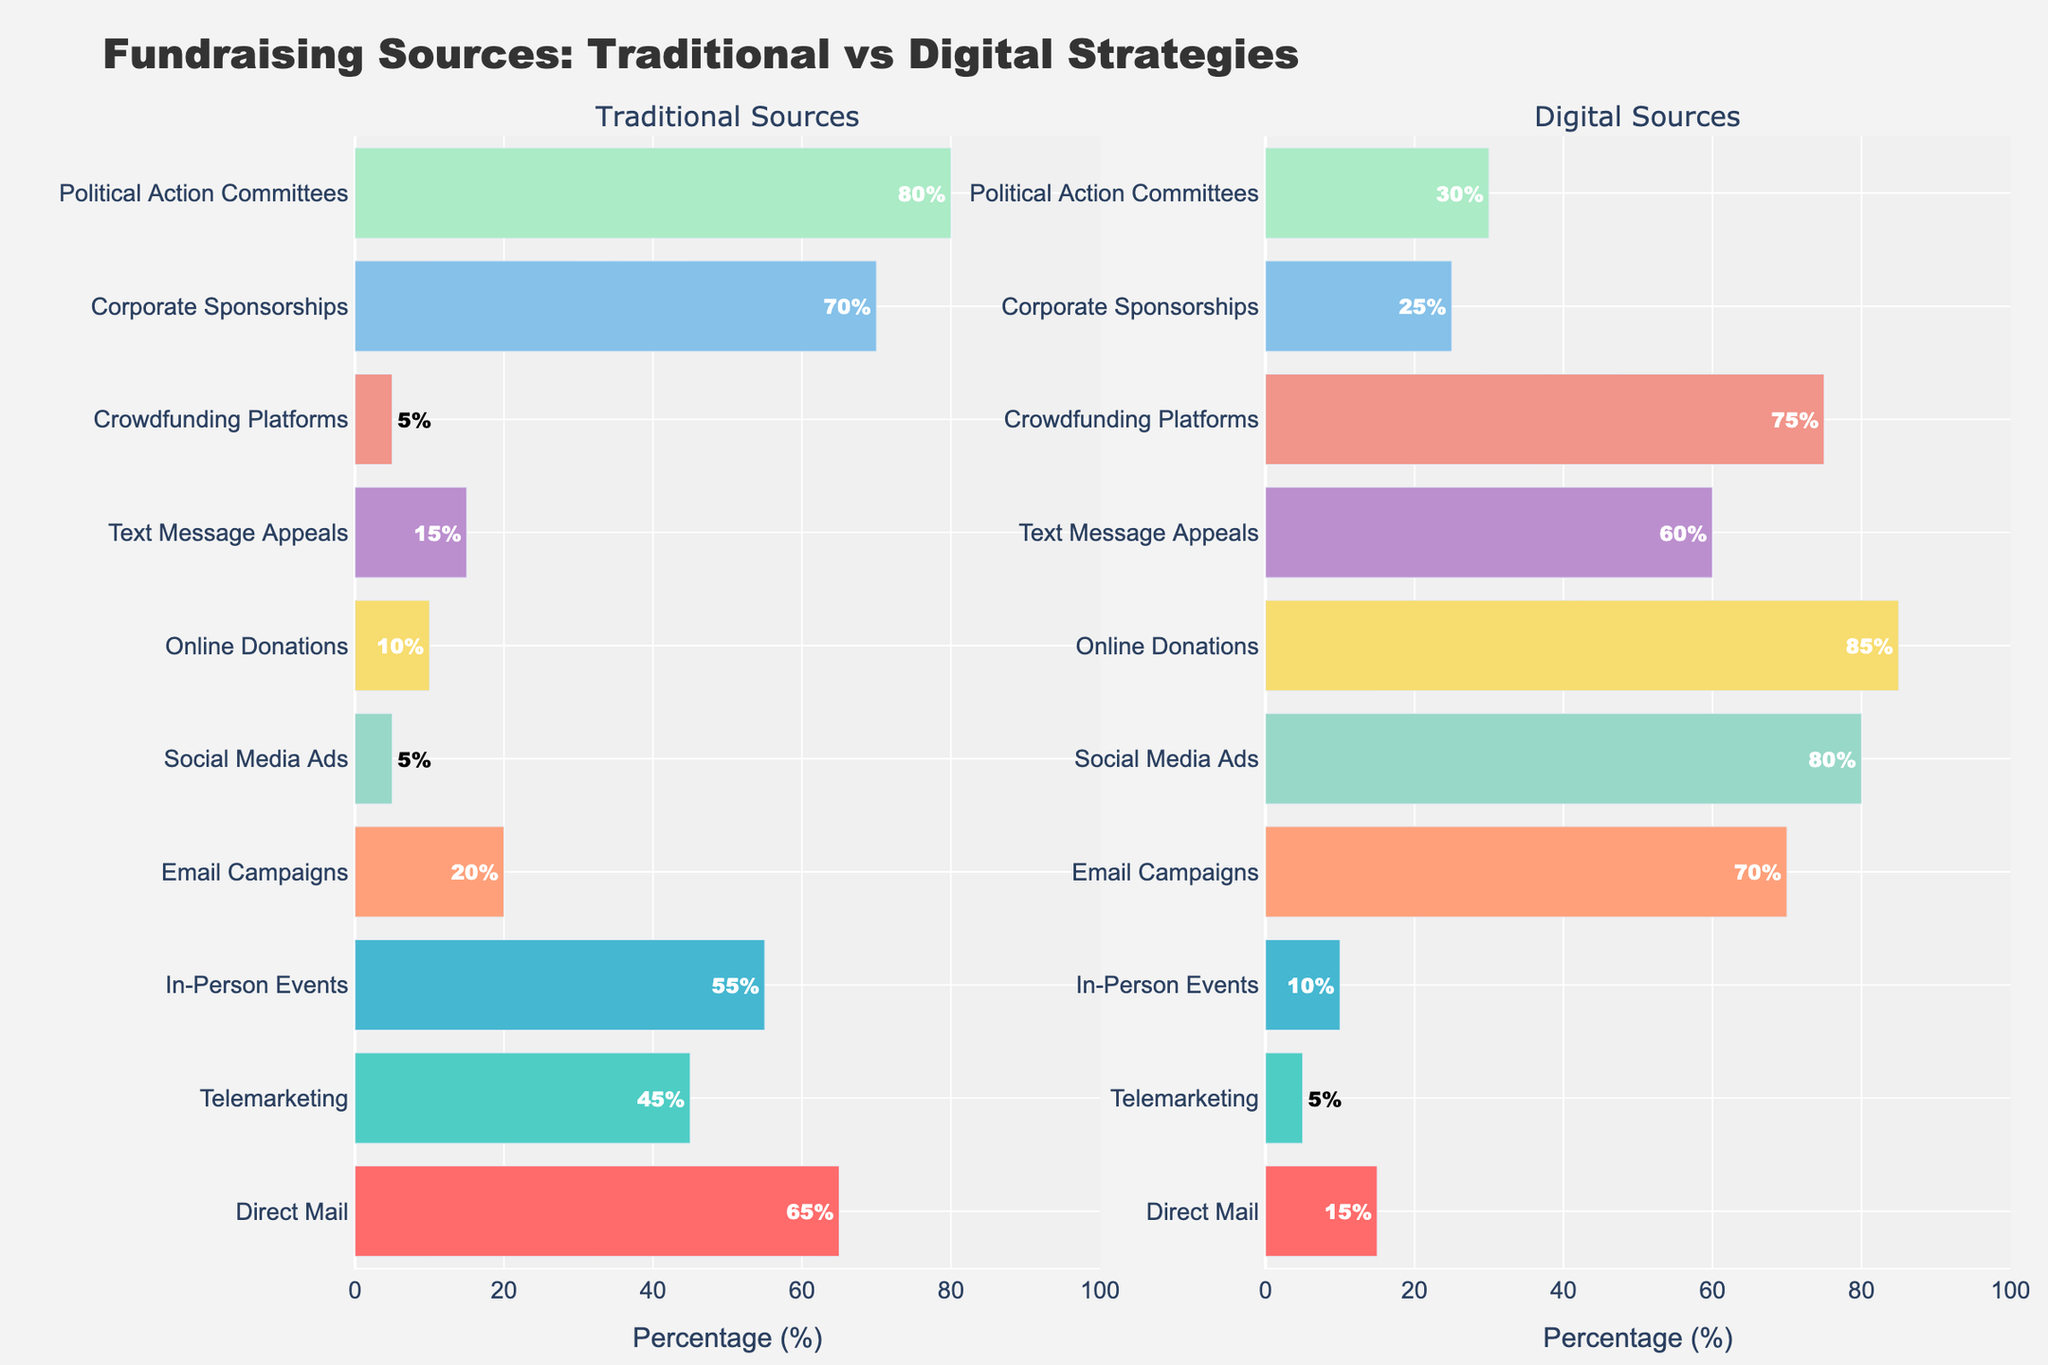What is the title of the subplot on the left? The title of the subplot on the left is given at the top of it.
Answer: Traditional Sources How many strategies have more than 50% in traditional sources? By looking at the bars on the left subplot, the ones that exceed the 50% mark are Direct Mail, Telemarketing, In-Person Events, Corporate Sponsorships, and Political Action Committees.
Answer: 5 Which fundraising source has the highest percentage in digital sources? Locate the longest bar in the right subplot to identify the source with the highest percentage.
Answer: Online Donations Compare the percentages of Direct Mail in traditional and digital sources. Which one is higher and by how much? Direct Mail in traditional sources is 65%, and in digital sources is 15%. The difference is 65% - 15%.
Answer: Traditional, by 50% What is the average percentage of all digital sources? Sum all the percentages of digital sources and divide them by the number of sources. (15 + 5 + 10 + 70 + 80 + 85 + 60 + 75 + 25 + 30) / 10.
Answer: 45.5% Identify the three sources with the lowest percentage in digital campaigns. The shortest bars in the right subplot are for Telemarketing, Direct Mail, and In-Person Events.
Answer: Telemarketing, Direct Mail, In-Person Events Which source has a higher percentage in traditional sources compared to its percentage in digital sources, In-Person Events or Political Action Committees? In-Person Events has 55% in traditional and 10% in digital. Political Action Committees have 80% in traditional and 30% in digital. Both are higher in traditional, but Political Action Committees is higher than In-Person Events in both cases.
Answer: Political Action Committees What is the combined percentage for Social Media Ads and Crowdfunding Platforms in digital sources? Add the percentages for Social Media Ads and Crowdfunding Platforms in digital sources: 80% + 75%.
Answer: 155% What source has the smallest difference in percentages between traditional and digital sources? Compare the absolute differences between traditional and digital sources for each fundraising strategy. Crowdfunding Platforms has the smallest difference (5% in traditional vs. 75% in digital).
Answer: Crowdfunding Platforms How many strategies have less than 30% in digital sources? Identify the bars less than 30% in the right subplot: Direct Mail, Telemarketing, In-Person Events, and Corporate Sponsorships.
Answer: 4 